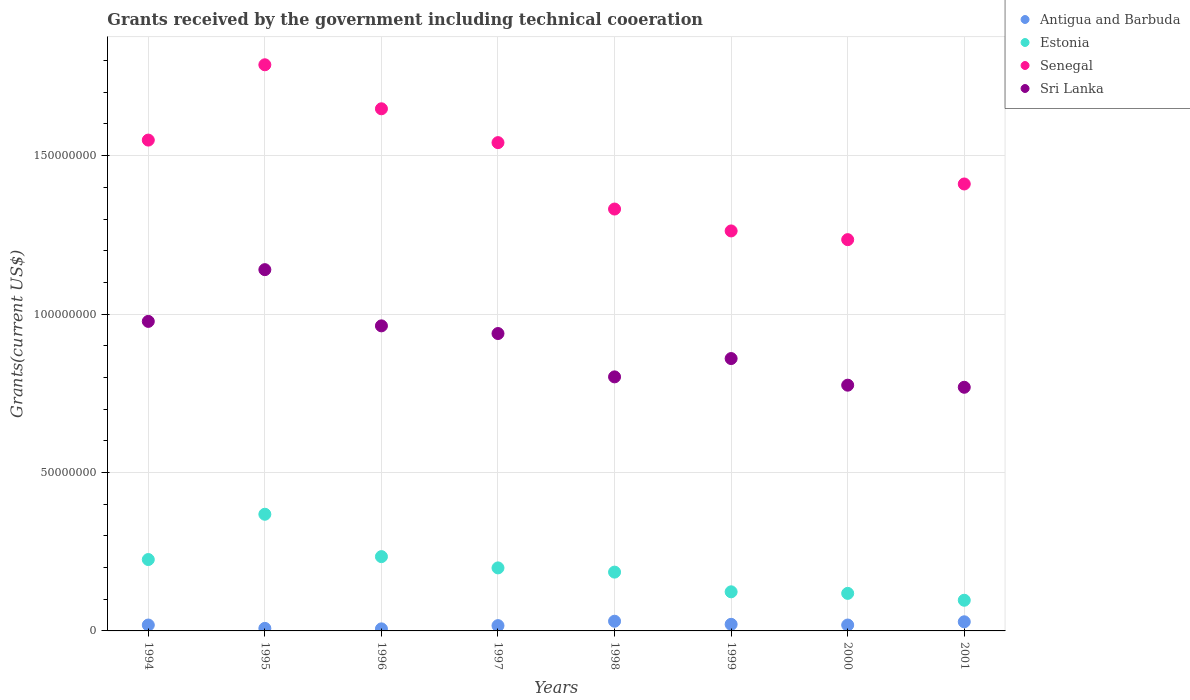How many different coloured dotlines are there?
Ensure brevity in your answer.  4. Is the number of dotlines equal to the number of legend labels?
Provide a succinct answer. Yes. What is the total grants received by the government in Estonia in 1999?
Keep it short and to the point. 1.23e+07. Across all years, what is the maximum total grants received by the government in Antigua and Barbuda?
Ensure brevity in your answer.  3.06e+06. Across all years, what is the minimum total grants received by the government in Senegal?
Make the answer very short. 1.23e+08. In which year was the total grants received by the government in Antigua and Barbuda maximum?
Your response must be concise. 1998. What is the total total grants received by the government in Estonia in the graph?
Your answer should be very brief. 1.55e+08. What is the difference between the total grants received by the government in Sri Lanka in 1994 and that in 1997?
Your answer should be compact. 3.83e+06. What is the difference between the total grants received by the government in Estonia in 1997 and the total grants received by the government in Antigua and Barbuda in 1995?
Keep it short and to the point. 1.91e+07. What is the average total grants received by the government in Senegal per year?
Your answer should be compact. 1.47e+08. In the year 1996, what is the difference between the total grants received by the government in Sri Lanka and total grants received by the government in Antigua and Barbuda?
Provide a succinct answer. 9.56e+07. In how many years, is the total grants received by the government in Antigua and Barbuda greater than 70000000 US$?
Offer a terse response. 0. What is the ratio of the total grants received by the government in Senegal in 2000 to that in 2001?
Provide a succinct answer. 0.88. Is the difference between the total grants received by the government in Sri Lanka in 1998 and 2001 greater than the difference between the total grants received by the government in Antigua and Barbuda in 1998 and 2001?
Your response must be concise. Yes. What is the difference between the highest and the second highest total grants received by the government in Estonia?
Your response must be concise. 1.34e+07. What is the difference between the highest and the lowest total grants received by the government in Antigua and Barbuda?
Keep it short and to the point. 2.41e+06. In how many years, is the total grants received by the government in Antigua and Barbuda greater than the average total grants received by the government in Antigua and Barbuda taken over all years?
Ensure brevity in your answer.  5. Is the sum of the total grants received by the government in Antigua and Barbuda in 1995 and 2000 greater than the maximum total grants received by the government in Estonia across all years?
Offer a very short reply. No. Is it the case that in every year, the sum of the total grants received by the government in Senegal and total grants received by the government in Estonia  is greater than the sum of total grants received by the government in Antigua and Barbuda and total grants received by the government in Sri Lanka?
Your answer should be very brief. Yes. Does the total grants received by the government in Sri Lanka monotonically increase over the years?
Your response must be concise. No. Is the total grants received by the government in Antigua and Barbuda strictly greater than the total grants received by the government in Sri Lanka over the years?
Offer a terse response. No. Is the total grants received by the government in Antigua and Barbuda strictly less than the total grants received by the government in Senegal over the years?
Offer a very short reply. Yes. How many dotlines are there?
Keep it short and to the point. 4. Are the values on the major ticks of Y-axis written in scientific E-notation?
Make the answer very short. No. Does the graph contain any zero values?
Make the answer very short. No. Does the graph contain grids?
Offer a terse response. Yes. Where does the legend appear in the graph?
Ensure brevity in your answer.  Top right. How are the legend labels stacked?
Ensure brevity in your answer.  Vertical. What is the title of the graph?
Provide a short and direct response. Grants received by the government including technical cooeration. Does "Malaysia" appear as one of the legend labels in the graph?
Keep it short and to the point. No. What is the label or title of the X-axis?
Your answer should be very brief. Years. What is the label or title of the Y-axis?
Keep it short and to the point. Grants(current US$). What is the Grants(current US$) of Antigua and Barbuda in 1994?
Provide a short and direct response. 1.86e+06. What is the Grants(current US$) in Estonia in 1994?
Provide a succinct answer. 2.25e+07. What is the Grants(current US$) in Senegal in 1994?
Your response must be concise. 1.55e+08. What is the Grants(current US$) of Sri Lanka in 1994?
Provide a succinct answer. 9.77e+07. What is the Grants(current US$) in Antigua and Barbuda in 1995?
Provide a succinct answer. 8.00e+05. What is the Grants(current US$) in Estonia in 1995?
Give a very brief answer. 3.68e+07. What is the Grants(current US$) in Senegal in 1995?
Keep it short and to the point. 1.79e+08. What is the Grants(current US$) of Sri Lanka in 1995?
Your answer should be very brief. 1.14e+08. What is the Grants(current US$) of Antigua and Barbuda in 1996?
Ensure brevity in your answer.  6.50e+05. What is the Grants(current US$) of Estonia in 1996?
Offer a very short reply. 2.34e+07. What is the Grants(current US$) of Senegal in 1996?
Offer a terse response. 1.65e+08. What is the Grants(current US$) in Sri Lanka in 1996?
Offer a very short reply. 9.63e+07. What is the Grants(current US$) of Antigua and Barbuda in 1997?
Make the answer very short. 1.67e+06. What is the Grants(current US$) in Estonia in 1997?
Your response must be concise. 1.99e+07. What is the Grants(current US$) of Senegal in 1997?
Keep it short and to the point. 1.54e+08. What is the Grants(current US$) in Sri Lanka in 1997?
Give a very brief answer. 9.39e+07. What is the Grants(current US$) in Antigua and Barbuda in 1998?
Provide a succinct answer. 3.06e+06. What is the Grants(current US$) of Estonia in 1998?
Your answer should be compact. 1.86e+07. What is the Grants(current US$) in Senegal in 1998?
Provide a succinct answer. 1.33e+08. What is the Grants(current US$) in Sri Lanka in 1998?
Provide a short and direct response. 8.02e+07. What is the Grants(current US$) of Antigua and Barbuda in 1999?
Your answer should be very brief. 2.08e+06. What is the Grants(current US$) of Estonia in 1999?
Your response must be concise. 1.23e+07. What is the Grants(current US$) of Senegal in 1999?
Make the answer very short. 1.26e+08. What is the Grants(current US$) in Sri Lanka in 1999?
Provide a succinct answer. 8.60e+07. What is the Grants(current US$) of Antigua and Barbuda in 2000?
Your answer should be compact. 1.86e+06. What is the Grants(current US$) of Estonia in 2000?
Your response must be concise. 1.18e+07. What is the Grants(current US$) of Senegal in 2000?
Keep it short and to the point. 1.23e+08. What is the Grants(current US$) in Sri Lanka in 2000?
Offer a terse response. 7.76e+07. What is the Grants(current US$) in Antigua and Barbuda in 2001?
Make the answer very short. 2.88e+06. What is the Grants(current US$) in Estonia in 2001?
Your answer should be compact. 9.68e+06. What is the Grants(current US$) in Senegal in 2001?
Offer a terse response. 1.41e+08. What is the Grants(current US$) of Sri Lanka in 2001?
Give a very brief answer. 7.69e+07. Across all years, what is the maximum Grants(current US$) of Antigua and Barbuda?
Make the answer very short. 3.06e+06. Across all years, what is the maximum Grants(current US$) in Estonia?
Offer a terse response. 3.68e+07. Across all years, what is the maximum Grants(current US$) in Senegal?
Make the answer very short. 1.79e+08. Across all years, what is the maximum Grants(current US$) in Sri Lanka?
Give a very brief answer. 1.14e+08. Across all years, what is the minimum Grants(current US$) of Antigua and Barbuda?
Ensure brevity in your answer.  6.50e+05. Across all years, what is the minimum Grants(current US$) of Estonia?
Offer a very short reply. 9.68e+06. Across all years, what is the minimum Grants(current US$) in Senegal?
Give a very brief answer. 1.23e+08. Across all years, what is the minimum Grants(current US$) of Sri Lanka?
Your answer should be compact. 7.69e+07. What is the total Grants(current US$) in Antigua and Barbuda in the graph?
Offer a terse response. 1.49e+07. What is the total Grants(current US$) in Estonia in the graph?
Your answer should be very brief. 1.55e+08. What is the total Grants(current US$) of Senegal in the graph?
Ensure brevity in your answer.  1.18e+09. What is the total Grants(current US$) of Sri Lanka in the graph?
Provide a short and direct response. 7.22e+08. What is the difference between the Grants(current US$) of Antigua and Barbuda in 1994 and that in 1995?
Make the answer very short. 1.06e+06. What is the difference between the Grants(current US$) of Estonia in 1994 and that in 1995?
Offer a very short reply. -1.43e+07. What is the difference between the Grants(current US$) of Senegal in 1994 and that in 1995?
Your answer should be very brief. -2.38e+07. What is the difference between the Grants(current US$) of Sri Lanka in 1994 and that in 1995?
Your response must be concise. -1.63e+07. What is the difference between the Grants(current US$) of Antigua and Barbuda in 1994 and that in 1996?
Offer a terse response. 1.21e+06. What is the difference between the Grants(current US$) of Estonia in 1994 and that in 1996?
Your answer should be very brief. -9.20e+05. What is the difference between the Grants(current US$) of Senegal in 1994 and that in 1996?
Provide a short and direct response. -9.88e+06. What is the difference between the Grants(current US$) in Sri Lanka in 1994 and that in 1996?
Ensure brevity in your answer.  1.41e+06. What is the difference between the Grants(current US$) in Estonia in 1994 and that in 1997?
Keep it short and to the point. 2.64e+06. What is the difference between the Grants(current US$) of Senegal in 1994 and that in 1997?
Ensure brevity in your answer.  8.00e+05. What is the difference between the Grants(current US$) in Sri Lanka in 1994 and that in 1997?
Provide a short and direct response. 3.83e+06. What is the difference between the Grants(current US$) in Antigua and Barbuda in 1994 and that in 1998?
Give a very brief answer. -1.20e+06. What is the difference between the Grants(current US$) of Estonia in 1994 and that in 1998?
Offer a terse response. 3.97e+06. What is the difference between the Grants(current US$) of Senegal in 1994 and that in 1998?
Make the answer very short. 2.18e+07. What is the difference between the Grants(current US$) of Sri Lanka in 1994 and that in 1998?
Give a very brief answer. 1.75e+07. What is the difference between the Grants(current US$) in Antigua and Barbuda in 1994 and that in 1999?
Offer a very short reply. -2.20e+05. What is the difference between the Grants(current US$) of Estonia in 1994 and that in 1999?
Offer a terse response. 1.02e+07. What is the difference between the Grants(current US$) of Senegal in 1994 and that in 1999?
Give a very brief answer. 2.87e+07. What is the difference between the Grants(current US$) in Sri Lanka in 1994 and that in 1999?
Give a very brief answer. 1.17e+07. What is the difference between the Grants(current US$) of Estonia in 1994 and that in 2000?
Your answer should be compact. 1.07e+07. What is the difference between the Grants(current US$) of Senegal in 1994 and that in 2000?
Provide a short and direct response. 3.14e+07. What is the difference between the Grants(current US$) of Sri Lanka in 1994 and that in 2000?
Your response must be concise. 2.01e+07. What is the difference between the Grants(current US$) in Antigua and Barbuda in 1994 and that in 2001?
Keep it short and to the point. -1.02e+06. What is the difference between the Grants(current US$) of Estonia in 1994 and that in 2001?
Offer a terse response. 1.28e+07. What is the difference between the Grants(current US$) in Senegal in 1994 and that in 2001?
Offer a very short reply. 1.38e+07. What is the difference between the Grants(current US$) of Sri Lanka in 1994 and that in 2001?
Your answer should be very brief. 2.08e+07. What is the difference between the Grants(current US$) of Antigua and Barbuda in 1995 and that in 1996?
Your answer should be very brief. 1.50e+05. What is the difference between the Grants(current US$) of Estonia in 1995 and that in 1996?
Ensure brevity in your answer.  1.34e+07. What is the difference between the Grants(current US$) of Senegal in 1995 and that in 1996?
Provide a succinct answer. 1.39e+07. What is the difference between the Grants(current US$) of Sri Lanka in 1995 and that in 1996?
Give a very brief answer. 1.77e+07. What is the difference between the Grants(current US$) of Antigua and Barbuda in 1995 and that in 1997?
Your response must be concise. -8.70e+05. What is the difference between the Grants(current US$) of Estonia in 1995 and that in 1997?
Give a very brief answer. 1.69e+07. What is the difference between the Grants(current US$) of Senegal in 1995 and that in 1997?
Provide a succinct answer. 2.46e+07. What is the difference between the Grants(current US$) of Sri Lanka in 1995 and that in 1997?
Make the answer very short. 2.02e+07. What is the difference between the Grants(current US$) in Antigua and Barbuda in 1995 and that in 1998?
Offer a terse response. -2.26e+06. What is the difference between the Grants(current US$) of Estonia in 1995 and that in 1998?
Provide a succinct answer. 1.83e+07. What is the difference between the Grants(current US$) in Senegal in 1995 and that in 1998?
Provide a succinct answer. 4.55e+07. What is the difference between the Grants(current US$) in Sri Lanka in 1995 and that in 1998?
Offer a terse response. 3.38e+07. What is the difference between the Grants(current US$) of Antigua and Barbuda in 1995 and that in 1999?
Your answer should be compact. -1.28e+06. What is the difference between the Grants(current US$) in Estonia in 1995 and that in 1999?
Ensure brevity in your answer.  2.45e+07. What is the difference between the Grants(current US$) in Senegal in 1995 and that in 1999?
Your response must be concise. 5.24e+07. What is the difference between the Grants(current US$) of Sri Lanka in 1995 and that in 1999?
Keep it short and to the point. 2.81e+07. What is the difference between the Grants(current US$) in Antigua and Barbuda in 1995 and that in 2000?
Your answer should be very brief. -1.06e+06. What is the difference between the Grants(current US$) in Estonia in 1995 and that in 2000?
Your answer should be very brief. 2.50e+07. What is the difference between the Grants(current US$) of Senegal in 1995 and that in 2000?
Offer a very short reply. 5.52e+07. What is the difference between the Grants(current US$) of Sri Lanka in 1995 and that in 2000?
Ensure brevity in your answer.  3.65e+07. What is the difference between the Grants(current US$) in Antigua and Barbuda in 1995 and that in 2001?
Provide a succinct answer. -2.08e+06. What is the difference between the Grants(current US$) in Estonia in 1995 and that in 2001?
Give a very brief answer. 2.71e+07. What is the difference between the Grants(current US$) in Senegal in 1995 and that in 2001?
Your response must be concise. 3.76e+07. What is the difference between the Grants(current US$) in Sri Lanka in 1995 and that in 2001?
Ensure brevity in your answer.  3.71e+07. What is the difference between the Grants(current US$) of Antigua and Barbuda in 1996 and that in 1997?
Keep it short and to the point. -1.02e+06. What is the difference between the Grants(current US$) of Estonia in 1996 and that in 1997?
Offer a very short reply. 3.56e+06. What is the difference between the Grants(current US$) of Senegal in 1996 and that in 1997?
Your answer should be very brief. 1.07e+07. What is the difference between the Grants(current US$) in Sri Lanka in 1996 and that in 1997?
Provide a succinct answer. 2.42e+06. What is the difference between the Grants(current US$) of Antigua and Barbuda in 1996 and that in 1998?
Give a very brief answer. -2.41e+06. What is the difference between the Grants(current US$) of Estonia in 1996 and that in 1998?
Your answer should be very brief. 4.89e+06. What is the difference between the Grants(current US$) of Senegal in 1996 and that in 1998?
Give a very brief answer. 3.16e+07. What is the difference between the Grants(current US$) in Sri Lanka in 1996 and that in 1998?
Offer a terse response. 1.61e+07. What is the difference between the Grants(current US$) in Antigua and Barbuda in 1996 and that in 1999?
Offer a very short reply. -1.43e+06. What is the difference between the Grants(current US$) in Estonia in 1996 and that in 1999?
Ensure brevity in your answer.  1.11e+07. What is the difference between the Grants(current US$) of Senegal in 1996 and that in 1999?
Provide a succinct answer. 3.86e+07. What is the difference between the Grants(current US$) in Sri Lanka in 1996 and that in 1999?
Provide a short and direct response. 1.03e+07. What is the difference between the Grants(current US$) of Antigua and Barbuda in 1996 and that in 2000?
Offer a very short reply. -1.21e+06. What is the difference between the Grants(current US$) of Estonia in 1996 and that in 2000?
Make the answer very short. 1.16e+07. What is the difference between the Grants(current US$) in Senegal in 1996 and that in 2000?
Offer a terse response. 4.13e+07. What is the difference between the Grants(current US$) in Sri Lanka in 1996 and that in 2000?
Offer a very short reply. 1.87e+07. What is the difference between the Grants(current US$) in Antigua and Barbuda in 1996 and that in 2001?
Make the answer very short. -2.23e+06. What is the difference between the Grants(current US$) in Estonia in 1996 and that in 2001?
Provide a succinct answer. 1.38e+07. What is the difference between the Grants(current US$) in Senegal in 1996 and that in 2001?
Offer a terse response. 2.37e+07. What is the difference between the Grants(current US$) of Sri Lanka in 1996 and that in 2001?
Your answer should be very brief. 1.94e+07. What is the difference between the Grants(current US$) of Antigua and Barbuda in 1997 and that in 1998?
Ensure brevity in your answer.  -1.39e+06. What is the difference between the Grants(current US$) of Estonia in 1997 and that in 1998?
Offer a very short reply. 1.33e+06. What is the difference between the Grants(current US$) of Senegal in 1997 and that in 1998?
Offer a very short reply. 2.10e+07. What is the difference between the Grants(current US$) in Sri Lanka in 1997 and that in 1998?
Your answer should be compact. 1.37e+07. What is the difference between the Grants(current US$) in Antigua and Barbuda in 1997 and that in 1999?
Your response must be concise. -4.10e+05. What is the difference between the Grants(current US$) in Estonia in 1997 and that in 1999?
Your response must be concise. 7.55e+06. What is the difference between the Grants(current US$) in Senegal in 1997 and that in 1999?
Ensure brevity in your answer.  2.79e+07. What is the difference between the Grants(current US$) of Sri Lanka in 1997 and that in 1999?
Provide a short and direct response. 7.90e+06. What is the difference between the Grants(current US$) of Estonia in 1997 and that in 2000?
Provide a short and direct response. 8.04e+06. What is the difference between the Grants(current US$) of Senegal in 1997 and that in 2000?
Your response must be concise. 3.06e+07. What is the difference between the Grants(current US$) of Sri Lanka in 1997 and that in 2000?
Your response must be concise. 1.63e+07. What is the difference between the Grants(current US$) in Antigua and Barbuda in 1997 and that in 2001?
Offer a terse response. -1.21e+06. What is the difference between the Grants(current US$) of Estonia in 1997 and that in 2001?
Offer a very short reply. 1.02e+07. What is the difference between the Grants(current US$) of Senegal in 1997 and that in 2001?
Give a very brief answer. 1.30e+07. What is the difference between the Grants(current US$) in Sri Lanka in 1997 and that in 2001?
Your response must be concise. 1.70e+07. What is the difference between the Grants(current US$) of Antigua and Barbuda in 1998 and that in 1999?
Offer a terse response. 9.80e+05. What is the difference between the Grants(current US$) in Estonia in 1998 and that in 1999?
Your answer should be very brief. 6.22e+06. What is the difference between the Grants(current US$) in Senegal in 1998 and that in 1999?
Your answer should be compact. 6.91e+06. What is the difference between the Grants(current US$) in Sri Lanka in 1998 and that in 1999?
Your answer should be very brief. -5.78e+06. What is the difference between the Grants(current US$) in Antigua and Barbuda in 1998 and that in 2000?
Your answer should be compact. 1.20e+06. What is the difference between the Grants(current US$) in Estonia in 1998 and that in 2000?
Ensure brevity in your answer.  6.71e+06. What is the difference between the Grants(current US$) in Senegal in 1998 and that in 2000?
Provide a succinct answer. 9.66e+06. What is the difference between the Grants(current US$) of Sri Lanka in 1998 and that in 2000?
Provide a short and direct response. 2.62e+06. What is the difference between the Grants(current US$) of Antigua and Barbuda in 1998 and that in 2001?
Your answer should be compact. 1.80e+05. What is the difference between the Grants(current US$) of Estonia in 1998 and that in 2001?
Provide a short and direct response. 8.88e+06. What is the difference between the Grants(current US$) in Senegal in 1998 and that in 2001?
Give a very brief answer. -7.91e+06. What is the difference between the Grants(current US$) in Sri Lanka in 1998 and that in 2001?
Your response must be concise. 3.28e+06. What is the difference between the Grants(current US$) of Antigua and Barbuda in 1999 and that in 2000?
Offer a very short reply. 2.20e+05. What is the difference between the Grants(current US$) in Senegal in 1999 and that in 2000?
Provide a succinct answer. 2.75e+06. What is the difference between the Grants(current US$) of Sri Lanka in 1999 and that in 2000?
Provide a short and direct response. 8.40e+06. What is the difference between the Grants(current US$) in Antigua and Barbuda in 1999 and that in 2001?
Keep it short and to the point. -8.00e+05. What is the difference between the Grants(current US$) in Estonia in 1999 and that in 2001?
Your answer should be compact. 2.66e+06. What is the difference between the Grants(current US$) of Senegal in 1999 and that in 2001?
Keep it short and to the point. -1.48e+07. What is the difference between the Grants(current US$) in Sri Lanka in 1999 and that in 2001?
Keep it short and to the point. 9.06e+06. What is the difference between the Grants(current US$) of Antigua and Barbuda in 2000 and that in 2001?
Your answer should be compact. -1.02e+06. What is the difference between the Grants(current US$) of Estonia in 2000 and that in 2001?
Offer a very short reply. 2.17e+06. What is the difference between the Grants(current US$) of Senegal in 2000 and that in 2001?
Provide a short and direct response. -1.76e+07. What is the difference between the Grants(current US$) of Antigua and Barbuda in 1994 and the Grants(current US$) of Estonia in 1995?
Your answer should be compact. -3.50e+07. What is the difference between the Grants(current US$) in Antigua and Barbuda in 1994 and the Grants(current US$) in Senegal in 1995?
Make the answer very short. -1.77e+08. What is the difference between the Grants(current US$) of Antigua and Barbuda in 1994 and the Grants(current US$) of Sri Lanka in 1995?
Ensure brevity in your answer.  -1.12e+08. What is the difference between the Grants(current US$) in Estonia in 1994 and the Grants(current US$) in Senegal in 1995?
Your answer should be compact. -1.56e+08. What is the difference between the Grants(current US$) of Estonia in 1994 and the Grants(current US$) of Sri Lanka in 1995?
Ensure brevity in your answer.  -9.15e+07. What is the difference between the Grants(current US$) in Senegal in 1994 and the Grants(current US$) in Sri Lanka in 1995?
Provide a short and direct response. 4.09e+07. What is the difference between the Grants(current US$) of Antigua and Barbuda in 1994 and the Grants(current US$) of Estonia in 1996?
Your response must be concise. -2.16e+07. What is the difference between the Grants(current US$) in Antigua and Barbuda in 1994 and the Grants(current US$) in Senegal in 1996?
Make the answer very short. -1.63e+08. What is the difference between the Grants(current US$) of Antigua and Barbuda in 1994 and the Grants(current US$) of Sri Lanka in 1996?
Give a very brief answer. -9.44e+07. What is the difference between the Grants(current US$) of Estonia in 1994 and the Grants(current US$) of Senegal in 1996?
Keep it short and to the point. -1.42e+08. What is the difference between the Grants(current US$) in Estonia in 1994 and the Grants(current US$) in Sri Lanka in 1996?
Your answer should be very brief. -7.38e+07. What is the difference between the Grants(current US$) of Senegal in 1994 and the Grants(current US$) of Sri Lanka in 1996?
Your answer should be compact. 5.86e+07. What is the difference between the Grants(current US$) of Antigua and Barbuda in 1994 and the Grants(current US$) of Estonia in 1997?
Provide a succinct answer. -1.80e+07. What is the difference between the Grants(current US$) of Antigua and Barbuda in 1994 and the Grants(current US$) of Senegal in 1997?
Give a very brief answer. -1.52e+08. What is the difference between the Grants(current US$) in Antigua and Barbuda in 1994 and the Grants(current US$) in Sri Lanka in 1997?
Your response must be concise. -9.20e+07. What is the difference between the Grants(current US$) in Estonia in 1994 and the Grants(current US$) in Senegal in 1997?
Your answer should be compact. -1.32e+08. What is the difference between the Grants(current US$) of Estonia in 1994 and the Grants(current US$) of Sri Lanka in 1997?
Ensure brevity in your answer.  -7.13e+07. What is the difference between the Grants(current US$) in Senegal in 1994 and the Grants(current US$) in Sri Lanka in 1997?
Offer a very short reply. 6.10e+07. What is the difference between the Grants(current US$) in Antigua and Barbuda in 1994 and the Grants(current US$) in Estonia in 1998?
Offer a very short reply. -1.67e+07. What is the difference between the Grants(current US$) in Antigua and Barbuda in 1994 and the Grants(current US$) in Senegal in 1998?
Keep it short and to the point. -1.31e+08. What is the difference between the Grants(current US$) in Antigua and Barbuda in 1994 and the Grants(current US$) in Sri Lanka in 1998?
Give a very brief answer. -7.83e+07. What is the difference between the Grants(current US$) in Estonia in 1994 and the Grants(current US$) in Senegal in 1998?
Ensure brevity in your answer.  -1.11e+08. What is the difference between the Grants(current US$) of Estonia in 1994 and the Grants(current US$) of Sri Lanka in 1998?
Ensure brevity in your answer.  -5.76e+07. What is the difference between the Grants(current US$) of Senegal in 1994 and the Grants(current US$) of Sri Lanka in 1998?
Provide a succinct answer. 7.47e+07. What is the difference between the Grants(current US$) of Antigua and Barbuda in 1994 and the Grants(current US$) of Estonia in 1999?
Your answer should be very brief. -1.05e+07. What is the difference between the Grants(current US$) of Antigua and Barbuda in 1994 and the Grants(current US$) of Senegal in 1999?
Keep it short and to the point. -1.24e+08. What is the difference between the Grants(current US$) of Antigua and Barbuda in 1994 and the Grants(current US$) of Sri Lanka in 1999?
Your answer should be very brief. -8.41e+07. What is the difference between the Grants(current US$) in Estonia in 1994 and the Grants(current US$) in Senegal in 1999?
Keep it short and to the point. -1.04e+08. What is the difference between the Grants(current US$) in Estonia in 1994 and the Grants(current US$) in Sri Lanka in 1999?
Your answer should be very brief. -6.34e+07. What is the difference between the Grants(current US$) of Senegal in 1994 and the Grants(current US$) of Sri Lanka in 1999?
Offer a very short reply. 6.90e+07. What is the difference between the Grants(current US$) in Antigua and Barbuda in 1994 and the Grants(current US$) in Estonia in 2000?
Give a very brief answer. -9.99e+06. What is the difference between the Grants(current US$) in Antigua and Barbuda in 1994 and the Grants(current US$) in Senegal in 2000?
Your answer should be compact. -1.22e+08. What is the difference between the Grants(current US$) of Antigua and Barbuda in 1994 and the Grants(current US$) of Sri Lanka in 2000?
Offer a terse response. -7.57e+07. What is the difference between the Grants(current US$) in Estonia in 1994 and the Grants(current US$) in Senegal in 2000?
Your answer should be very brief. -1.01e+08. What is the difference between the Grants(current US$) in Estonia in 1994 and the Grants(current US$) in Sri Lanka in 2000?
Keep it short and to the point. -5.50e+07. What is the difference between the Grants(current US$) of Senegal in 1994 and the Grants(current US$) of Sri Lanka in 2000?
Ensure brevity in your answer.  7.74e+07. What is the difference between the Grants(current US$) of Antigua and Barbuda in 1994 and the Grants(current US$) of Estonia in 2001?
Your answer should be compact. -7.82e+06. What is the difference between the Grants(current US$) of Antigua and Barbuda in 1994 and the Grants(current US$) of Senegal in 2001?
Your answer should be very brief. -1.39e+08. What is the difference between the Grants(current US$) of Antigua and Barbuda in 1994 and the Grants(current US$) of Sri Lanka in 2001?
Offer a very short reply. -7.50e+07. What is the difference between the Grants(current US$) of Estonia in 1994 and the Grants(current US$) of Senegal in 2001?
Make the answer very short. -1.19e+08. What is the difference between the Grants(current US$) in Estonia in 1994 and the Grants(current US$) in Sri Lanka in 2001?
Provide a succinct answer. -5.44e+07. What is the difference between the Grants(current US$) of Senegal in 1994 and the Grants(current US$) of Sri Lanka in 2001?
Offer a very short reply. 7.80e+07. What is the difference between the Grants(current US$) in Antigua and Barbuda in 1995 and the Grants(current US$) in Estonia in 1996?
Your answer should be very brief. -2.26e+07. What is the difference between the Grants(current US$) of Antigua and Barbuda in 1995 and the Grants(current US$) of Senegal in 1996?
Your answer should be very brief. -1.64e+08. What is the difference between the Grants(current US$) in Antigua and Barbuda in 1995 and the Grants(current US$) in Sri Lanka in 1996?
Provide a short and direct response. -9.55e+07. What is the difference between the Grants(current US$) in Estonia in 1995 and the Grants(current US$) in Senegal in 1996?
Keep it short and to the point. -1.28e+08. What is the difference between the Grants(current US$) of Estonia in 1995 and the Grants(current US$) of Sri Lanka in 1996?
Your response must be concise. -5.95e+07. What is the difference between the Grants(current US$) in Senegal in 1995 and the Grants(current US$) in Sri Lanka in 1996?
Keep it short and to the point. 8.24e+07. What is the difference between the Grants(current US$) of Antigua and Barbuda in 1995 and the Grants(current US$) of Estonia in 1997?
Your response must be concise. -1.91e+07. What is the difference between the Grants(current US$) in Antigua and Barbuda in 1995 and the Grants(current US$) in Senegal in 1997?
Your answer should be compact. -1.53e+08. What is the difference between the Grants(current US$) of Antigua and Barbuda in 1995 and the Grants(current US$) of Sri Lanka in 1997?
Provide a short and direct response. -9.31e+07. What is the difference between the Grants(current US$) of Estonia in 1995 and the Grants(current US$) of Senegal in 1997?
Your response must be concise. -1.17e+08. What is the difference between the Grants(current US$) in Estonia in 1995 and the Grants(current US$) in Sri Lanka in 1997?
Your answer should be compact. -5.70e+07. What is the difference between the Grants(current US$) in Senegal in 1995 and the Grants(current US$) in Sri Lanka in 1997?
Your answer should be very brief. 8.48e+07. What is the difference between the Grants(current US$) in Antigua and Barbuda in 1995 and the Grants(current US$) in Estonia in 1998?
Provide a short and direct response. -1.78e+07. What is the difference between the Grants(current US$) of Antigua and Barbuda in 1995 and the Grants(current US$) of Senegal in 1998?
Provide a succinct answer. -1.32e+08. What is the difference between the Grants(current US$) in Antigua and Barbuda in 1995 and the Grants(current US$) in Sri Lanka in 1998?
Your answer should be very brief. -7.94e+07. What is the difference between the Grants(current US$) of Estonia in 1995 and the Grants(current US$) of Senegal in 1998?
Give a very brief answer. -9.63e+07. What is the difference between the Grants(current US$) of Estonia in 1995 and the Grants(current US$) of Sri Lanka in 1998?
Offer a very short reply. -4.34e+07. What is the difference between the Grants(current US$) in Senegal in 1995 and the Grants(current US$) in Sri Lanka in 1998?
Offer a very short reply. 9.85e+07. What is the difference between the Grants(current US$) of Antigua and Barbuda in 1995 and the Grants(current US$) of Estonia in 1999?
Ensure brevity in your answer.  -1.15e+07. What is the difference between the Grants(current US$) in Antigua and Barbuda in 1995 and the Grants(current US$) in Senegal in 1999?
Give a very brief answer. -1.25e+08. What is the difference between the Grants(current US$) of Antigua and Barbuda in 1995 and the Grants(current US$) of Sri Lanka in 1999?
Give a very brief answer. -8.52e+07. What is the difference between the Grants(current US$) of Estonia in 1995 and the Grants(current US$) of Senegal in 1999?
Give a very brief answer. -8.94e+07. What is the difference between the Grants(current US$) in Estonia in 1995 and the Grants(current US$) in Sri Lanka in 1999?
Give a very brief answer. -4.91e+07. What is the difference between the Grants(current US$) of Senegal in 1995 and the Grants(current US$) of Sri Lanka in 1999?
Provide a succinct answer. 9.27e+07. What is the difference between the Grants(current US$) in Antigua and Barbuda in 1995 and the Grants(current US$) in Estonia in 2000?
Your answer should be compact. -1.10e+07. What is the difference between the Grants(current US$) of Antigua and Barbuda in 1995 and the Grants(current US$) of Senegal in 2000?
Make the answer very short. -1.23e+08. What is the difference between the Grants(current US$) of Antigua and Barbuda in 1995 and the Grants(current US$) of Sri Lanka in 2000?
Your answer should be very brief. -7.68e+07. What is the difference between the Grants(current US$) of Estonia in 1995 and the Grants(current US$) of Senegal in 2000?
Your answer should be compact. -8.67e+07. What is the difference between the Grants(current US$) of Estonia in 1995 and the Grants(current US$) of Sri Lanka in 2000?
Your response must be concise. -4.07e+07. What is the difference between the Grants(current US$) in Senegal in 1995 and the Grants(current US$) in Sri Lanka in 2000?
Give a very brief answer. 1.01e+08. What is the difference between the Grants(current US$) in Antigua and Barbuda in 1995 and the Grants(current US$) in Estonia in 2001?
Provide a short and direct response. -8.88e+06. What is the difference between the Grants(current US$) in Antigua and Barbuda in 1995 and the Grants(current US$) in Senegal in 2001?
Keep it short and to the point. -1.40e+08. What is the difference between the Grants(current US$) of Antigua and Barbuda in 1995 and the Grants(current US$) of Sri Lanka in 2001?
Provide a succinct answer. -7.61e+07. What is the difference between the Grants(current US$) of Estonia in 1995 and the Grants(current US$) of Senegal in 2001?
Offer a terse response. -1.04e+08. What is the difference between the Grants(current US$) in Estonia in 1995 and the Grants(current US$) in Sri Lanka in 2001?
Keep it short and to the point. -4.01e+07. What is the difference between the Grants(current US$) in Senegal in 1995 and the Grants(current US$) in Sri Lanka in 2001?
Your response must be concise. 1.02e+08. What is the difference between the Grants(current US$) in Antigua and Barbuda in 1996 and the Grants(current US$) in Estonia in 1997?
Provide a short and direct response. -1.92e+07. What is the difference between the Grants(current US$) of Antigua and Barbuda in 1996 and the Grants(current US$) of Senegal in 1997?
Give a very brief answer. -1.53e+08. What is the difference between the Grants(current US$) of Antigua and Barbuda in 1996 and the Grants(current US$) of Sri Lanka in 1997?
Your response must be concise. -9.32e+07. What is the difference between the Grants(current US$) of Estonia in 1996 and the Grants(current US$) of Senegal in 1997?
Give a very brief answer. -1.31e+08. What is the difference between the Grants(current US$) in Estonia in 1996 and the Grants(current US$) in Sri Lanka in 1997?
Give a very brief answer. -7.04e+07. What is the difference between the Grants(current US$) of Senegal in 1996 and the Grants(current US$) of Sri Lanka in 1997?
Give a very brief answer. 7.09e+07. What is the difference between the Grants(current US$) of Antigua and Barbuda in 1996 and the Grants(current US$) of Estonia in 1998?
Offer a terse response. -1.79e+07. What is the difference between the Grants(current US$) in Antigua and Barbuda in 1996 and the Grants(current US$) in Senegal in 1998?
Keep it short and to the point. -1.32e+08. What is the difference between the Grants(current US$) in Antigua and Barbuda in 1996 and the Grants(current US$) in Sri Lanka in 1998?
Your response must be concise. -7.95e+07. What is the difference between the Grants(current US$) of Estonia in 1996 and the Grants(current US$) of Senegal in 1998?
Make the answer very short. -1.10e+08. What is the difference between the Grants(current US$) in Estonia in 1996 and the Grants(current US$) in Sri Lanka in 1998?
Give a very brief answer. -5.67e+07. What is the difference between the Grants(current US$) in Senegal in 1996 and the Grants(current US$) in Sri Lanka in 1998?
Ensure brevity in your answer.  8.46e+07. What is the difference between the Grants(current US$) of Antigua and Barbuda in 1996 and the Grants(current US$) of Estonia in 1999?
Give a very brief answer. -1.17e+07. What is the difference between the Grants(current US$) of Antigua and Barbuda in 1996 and the Grants(current US$) of Senegal in 1999?
Keep it short and to the point. -1.26e+08. What is the difference between the Grants(current US$) of Antigua and Barbuda in 1996 and the Grants(current US$) of Sri Lanka in 1999?
Give a very brief answer. -8.53e+07. What is the difference between the Grants(current US$) in Estonia in 1996 and the Grants(current US$) in Senegal in 1999?
Ensure brevity in your answer.  -1.03e+08. What is the difference between the Grants(current US$) of Estonia in 1996 and the Grants(current US$) of Sri Lanka in 1999?
Your response must be concise. -6.25e+07. What is the difference between the Grants(current US$) of Senegal in 1996 and the Grants(current US$) of Sri Lanka in 1999?
Your response must be concise. 7.88e+07. What is the difference between the Grants(current US$) of Antigua and Barbuda in 1996 and the Grants(current US$) of Estonia in 2000?
Your answer should be compact. -1.12e+07. What is the difference between the Grants(current US$) of Antigua and Barbuda in 1996 and the Grants(current US$) of Senegal in 2000?
Offer a terse response. -1.23e+08. What is the difference between the Grants(current US$) in Antigua and Barbuda in 1996 and the Grants(current US$) in Sri Lanka in 2000?
Your answer should be compact. -7.69e+07. What is the difference between the Grants(current US$) of Estonia in 1996 and the Grants(current US$) of Senegal in 2000?
Your answer should be very brief. -1.00e+08. What is the difference between the Grants(current US$) in Estonia in 1996 and the Grants(current US$) in Sri Lanka in 2000?
Your response must be concise. -5.41e+07. What is the difference between the Grants(current US$) of Senegal in 1996 and the Grants(current US$) of Sri Lanka in 2000?
Your answer should be very brief. 8.72e+07. What is the difference between the Grants(current US$) of Antigua and Barbuda in 1996 and the Grants(current US$) of Estonia in 2001?
Your answer should be very brief. -9.03e+06. What is the difference between the Grants(current US$) in Antigua and Barbuda in 1996 and the Grants(current US$) in Senegal in 2001?
Keep it short and to the point. -1.40e+08. What is the difference between the Grants(current US$) in Antigua and Barbuda in 1996 and the Grants(current US$) in Sri Lanka in 2001?
Give a very brief answer. -7.62e+07. What is the difference between the Grants(current US$) of Estonia in 1996 and the Grants(current US$) of Senegal in 2001?
Ensure brevity in your answer.  -1.18e+08. What is the difference between the Grants(current US$) of Estonia in 1996 and the Grants(current US$) of Sri Lanka in 2001?
Keep it short and to the point. -5.34e+07. What is the difference between the Grants(current US$) of Senegal in 1996 and the Grants(current US$) of Sri Lanka in 2001?
Your response must be concise. 8.79e+07. What is the difference between the Grants(current US$) in Antigua and Barbuda in 1997 and the Grants(current US$) in Estonia in 1998?
Provide a succinct answer. -1.69e+07. What is the difference between the Grants(current US$) in Antigua and Barbuda in 1997 and the Grants(current US$) in Senegal in 1998?
Provide a succinct answer. -1.31e+08. What is the difference between the Grants(current US$) of Antigua and Barbuda in 1997 and the Grants(current US$) of Sri Lanka in 1998?
Offer a very short reply. -7.85e+07. What is the difference between the Grants(current US$) of Estonia in 1997 and the Grants(current US$) of Senegal in 1998?
Make the answer very short. -1.13e+08. What is the difference between the Grants(current US$) in Estonia in 1997 and the Grants(current US$) in Sri Lanka in 1998?
Your answer should be very brief. -6.03e+07. What is the difference between the Grants(current US$) of Senegal in 1997 and the Grants(current US$) of Sri Lanka in 1998?
Your answer should be compact. 7.39e+07. What is the difference between the Grants(current US$) in Antigua and Barbuda in 1997 and the Grants(current US$) in Estonia in 1999?
Your answer should be compact. -1.07e+07. What is the difference between the Grants(current US$) of Antigua and Barbuda in 1997 and the Grants(current US$) of Senegal in 1999?
Give a very brief answer. -1.25e+08. What is the difference between the Grants(current US$) of Antigua and Barbuda in 1997 and the Grants(current US$) of Sri Lanka in 1999?
Give a very brief answer. -8.43e+07. What is the difference between the Grants(current US$) of Estonia in 1997 and the Grants(current US$) of Senegal in 1999?
Keep it short and to the point. -1.06e+08. What is the difference between the Grants(current US$) of Estonia in 1997 and the Grants(current US$) of Sri Lanka in 1999?
Give a very brief answer. -6.61e+07. What is the difference between the Grants(current US$) of Senegal in 1997 and the Grants(current US$) of Sri Lanka in 1999?
Offer a terse response. 6.82e+07. What is the difference between the Grants(current US$) in Antigua and Barbuda in 1997 and the Grants(current US$) in Estonia in 2000?
Your answer should be very brief. -1.02e+07. What is the difference between the Grants(current US$) of Antigua and Barbuda in 1997 and the Grants(current US$) of Senegal in 2000?
Offer a terse response. -1.22e+08. What is the difference between the Grants(current US$) of Antigua and Barbuda in 1997 and the Grants(current US$) of Sri Lanka in 2000?
Offer a very short reply. -7.59e+07. What is the difference between the Grants(current US$) of Estonia in 1997 and the Grants(current US$) of Senegal in 2000?
Your answer should be compact. -1.04e+08. What is the difference between the Grants(current US$) in Estonia in 1997 and the Grants(current US$) in Sri Lanka in 2000?
Provide a succinct answer. -5.77e+07. What is the difference between the Grants(current US$) in Senegal in 1997 and the Grants(current US$) in Sri Lanka in 2000?
Keep it short and to the point. 7.66e+07. What is the difference between the Grants(current US$) of Antigua and Barbuda in 1997 and the Grants(current US$) of Estonia in 2001?
Keep it short and to the point. -8.01e+06. What is the difference between the Grants(current US$) of Antigua and Barbuda in 1997 and the Grants(current US$) of Senegal in 2001?
Your response must be concise. -1.39e+08. What is the difference between the Grants(current US$) in Antigua and Barbuda in 1997 and the Grants(current US$) in Sri Lanka in 2001?
Keep it short and to the point. -7.52e+07. What is the difference between the Grants(current US$) of Estonia in 1997 and the Grants(current US$) of Senegal in 2001?
Provide a succinct answer. -1.21e+08. What is the difference between the Grants(current US$) of Estonia in 1997 and the Grants(current US$) of Sri Lanka in 2001?
Provide a succinct answer. -5.70e+07. What is the difference between the Grants(current US$) in Senegal in 1997 and the Grants(current US$) in Sri Lanka in 2001?
Offer a very short reply. 7.72e+07. What is the difference between the Grants(current US$) in Antigua and Barbuda in 1998 and the Grants(current US$) in Estonia in 1999?
Keep it short and to the point. -9.28e+06. What is the difference between the Grants(current US$) in Antigua and Barbuda in 1998 and the Grants(current US$) in Senegal in 1999?
Your answer should be compact. -1.23e+08. What is the difference between the Grants(current US$) in Antigua and Barbuda in 1998 and the Grants(current US$) in Sri Lanka in 1999?
Provide a succinct answer. -8.29e+07. What is the difference between the Grants(current US$) in Estonia in 1998 and the Grants(current US$) in Senegal in 1999?
Provide a short and direct response. -1.08e+08. What is the difference between the Grants(current US$) of Estonia in 1998 and the Grants(current US$) of Sri Lanka in 1999?
Provide a short and direct response. -6.74e+07. What is the difference between the Grants(current US$) in Senegal in 1998 and the Grants(current US$) in Sri Lanka in 1999?
Give a very brief answer. 4.72e+07. What is the difference between the Grants(current US$) in Antigua and Barbuda in 1998 and the Grants(current US$) in Estonia in 2000?
Make the answer very short. -8.79e+06. What is the difference between the Grants(current US$) of Antigua and Barbuda in 1998 and the Grants(current US$) of Senegal in 2000?
Keep it short and to the point. -1.20e+08. What is the difference between the Grants(current US$) of Antigua and Barbuda in 1998 and the Grants(current US$) of Sri Lanka in 2000?
Your response must be concise. -7.45e+07. What is the difference between the Grants(current US$) of Estonia in 1998 and the Grants(current US$) of Senegal in 2000?
Your answer should be compact. -1.05e+08. What is the difference between the Grants(current US$) in Estonia in 1998 and the Grants(current US$) in Sri Lanka in 2000?
Give a very brief answer. -5.90e+07. What is the difference between the Grants(current US$) in Senegal in 1998 and the Grants(current US$) in Sri Lanka in 2000?
Your response must be concise. 5.56e+07. What is the difference between the Grants(current US$) of Antigua and Barbuda in 1998 and the Grants(current US$) of Estonia in 2001?
Your answer should be very brief. -6.62e+06. What is the difference between the Grants(current US$) in Antigua and Barbuda in 1998 and the Grants(current US$) in Senegal in 2001?
Your answer should be compact. -1.38e+08. What is the difference between the Grants(current US$) of Antigua and Barbuda in 1998 and the Grants(current US$) of Sri Lanka in 2001?
Provide a succinct answer. -7.38e+07. What is the difference between the Grants(current US$) in Estonia in 1998 and the Grants(current US$) in Senegal in 2001?
Your response must be concise. -1.22e+08. What is the difference between the Grants(current US$) in Estonia in 1998 and the Grants(current US$) in Sri Lanka in 2001?
Your response must be concise. -5.83e+07. What is the difference between the Grants(current US$) in Senegal in 1998 and the Grants(current US$) in Sri Lanka in 2001?
Provide a short and direct response. 5.62e+07. What is the difference between the Grants(current US$) in Antigua and Barbuda in 1999 and the Grants(current US$) in Estonia in 2000?
Your answer should be compact. -9.77e+06. What is the difference between the Grants(current US$) in Antigua and Barbuda in 1999 and the Grants(current US$) in Senegal in 2000?
Offer a very short reply. -1.21e+08. What is the difference between the Grants(current US$) of Antigua and Barbuda in 1999 and the Grants(current US$) of Sri Lanka in 2000?
Give a very brief answer. -7.55e+07. What is the difference between the Grants(current US$) of Estonia in 1999 and the Grants(current US$) of Senegal in 2000?
Keep it short and to the point. -1.11e+08. What is the difference between the Grants(current US$) of Estonia in 1999 and the Grants(current US$) of Sri Lanka in 2000?
Provide a succinct answer. -6.52e+07. What is the difference between the Grants(current US$) of Senegal in 1999 and the Grants(current US$) of Sri Lanka in 2000?
Offer a very short reply. 4.87e+07. What is the difference between the Grants(current US$) of Antigua and Barbuda in 1999 and the Grants(current US$) of Estonia in 2001?
Give a very brief answer. -7.60e+06. What is the difference between the Grants(current US$) of Antigua and Barbuda in 1999 and the Grants(current US$) of Senegal in 2001?
Your response must be concise. -1.39e+08. What is the difference between the Grants(current US$) in Antigua and Barbuda in 1999 and the Grants(current US$) in Sri Lanka in 2001?
Offer a very short reply. -7.48e+07. What is the difference between the Grants(current US$) in Estonia in 1999 and the Grants(current US$) in Senegal in 2001?
Make the answer very short. -1.29e+08. What is the difference between the Grants(current US$) of Estonia in 1999 and the Grants(current US$) of Sri Lanka in 2001?
Provide a succinct answer. -6.46e+07. What is the difference between the Grants(current US$) of Senegal in 1999 and the Grants(current US$) of Sri Lanka in 2001?
Your response must be concise. 4.93e+07. What is the difference between the Grants(current US$) of Antigua and Barbuda in 2000 and the Grants(current US$) of Estonia in 2001?
Ensure brevity in your answer.  -7.82e+06. What is the difference between the Grants(current US$) of Antigua and Barbuda in 2000 and the Grants(current US$) of Senegal in 2001?
Provide a short and direct response. -1.39e+08. What is the difference between the Grants(current US$) in Antigua and Barbuda in 2000 and the Grants(current US$) in Sri Lanka in 2001?
Give a very brief answer. -7.50e+07. What is the difference between the Grants(current US$) of Estonia in 2000 and the Grants(current US$) of Senegal in 2001?
Your answer should be compact. -1.29e+08. What is the difference between the Grants(current US$) in Estonia in 2000 and the Grants(current US$) in Sri Lanka in 2001?
Keep it short and to the point. -6.50e+07. What is the difference between the Grants(current US$) in Senegal in 2000 and the Grants(current US$) in Sri Lanka in 2001?
Your response must be concise. 4.66e+07. What is the average Grants(current US$) in Antigua and Barbuda per year?
Offer a terse response. 1.86e+06. What is the average Grants(current US$) in Estonia per year?
Give a very brief answer. 1.94e+07. What is the average Grants(current US$) of Senegal per year?
Provide a succinct answer. 1.47e+08. What is the average Grants(current US$) of Sri Lanka per year?
Keep it short and to the point. 9.03e+07. In the year 1994, what is the difference between the Grants(current US$) of Antigua and Barbuda and Grants(current US$) of Estonia?
Your answer should be compact. -2.07e+07. In the year 1994, what is the difference between the Grants(current US$) in Antigua and Barbuda and Grants(current US$) in Senegal?
Make the answer very short. -1.53e+08. In the year 1994, what is the difference between the Grants(current US$) of Antigua and Barbuda and Grants(current US$) of Sri Lanka?
Provide a short and direct response. -9.58e+07. In the year 1994, what is the difference between the Grants(current US$) of Estonia and Grants(current US$) of Senegal?
Your response must be concise. -1.32e+08. In the year 1994, what is the difference between the Grants(current US$) of Estonia and Grants(current US$) of Sri Lanka?
Make the answer very short. -7.52e+07. In the year 1994, what is the difference between the Grants(current US$) in Senegal and Grants(current US$) in Sri Lanka?
Give a very brief answer. 5.72e+07. In the year 1995, what is the difference between the Grants(current US$) of Antigua and Barbuda and Grants(current US$) of Estonia?
Offer a very short reply. -3.60e+07. In the year 1995, what is the difference between the Grants(current US$) of Antigua and Barbuda and Grants(current US$) of Senegal?
Keep it short and to the point. -1.78e+08. In the year 1995, what is the difference between the Grants(current US$) of Antigua and Barbuda and Grants(current US$) of Sri Lanka?
Make the answer very short. -1.13e+08. In the year 1995, what is the difference between the Grants(current US$) of Estonia and Grants(current US$) of Senegal?
Give a very brief answer. -1.42e+08. In the year 1995, what is the difference between the Grants(current US$) in Estonia and Grants(current US$) in Sri Lanka?
Offer a terse response. -7.72e+07. In the year 1995, what is the difference between the Grants(current US$) in Senegal and Grants(current US$) in Sri Lanka?
Your answer should be very brief. 6.47e+07. In the year 1996, what is the difference between the Grants(current US$) in Antigua and Barbuda and Grants(current US$) in Estonia?
Offer a very short reply. -2.28e+07. In the year 1996, what is the difference between the Grants(current US$) in Antigua and Barbuda and Grants(current US$) in Senegal?
Your answer should be very brief. -1.64e+08. In the year 1996, what is the difference between the Grants(current US$) of Antigua and Barbuda and Grants(current US$) of Sri Lanka?
Offer a terse response. -9.56e+07. In the year 1996, what is the difference between the Grants(current US$) in Estonia and Grants(current US$) in Senegal?
Keep it short and to the point. -1.41e+08. In the year 1996, what is the difference between the Grants(current US$) in Estonia and Grants(current US$) in Sri Lanka?
Offer a very short reply. -7.28e+07. In the year 1996, what is the difference between the Grants(current US$) in Senegal and Grants(current US$) in Sri Lanka?
Offer a terse response. 6.85e+07. In the year 1997, what is the difference between the Grants(current US$) in Antigua and Barbuda and Grants(current US$) in Estonia?
Make the answer very short. -1.82e+07. In the year 1997, what is the difference between the Grants(current US$) in Antigua and Barbuda and Grants(current US$) in Senegal?
Ensure brevity in your answer.  -1.52e+08. In the year 1997, what is the difference between the Grants(current US$) of Antigua and Barbuda and Grants(current US$) of Sri Lanka?
Your answer should be very brief. -9.22e+07. In the year 1997, what is the difference between the Grants(current US$) in Estonia and Grants(current US$) in Senegal?
Offer a terse response. -1.34e+08. In the year 1997, what is the difference between the Grants(current US$) of Estonia and Grants(current US$) of Sri Lanka?
Provide a short and direct response. -7.40e+07. In the year 1997, what is the difference between the Grants(current US$) of Senegal and Grants(current US$) of Sri Lanka?
Give a very brief answer. 6.02e+07. In the year 1998, what is the difference between the Grants(current US$) in Antigua and Barbuda and Grants(current US$) in Estonia?
Make the answer very short. -1.55e+07. In the year 1998, what is the difference between the Grants(current US$) of Antigua and Barbuda and Grants(current US$) of Senegal?
Your response must be concise. -1.30e+08. In the year 1998, what is the difference between the Grants(current US$) of Antigua and Barbuda and Grants(current US$) of Sri Lanka?
Offer a terse response. -7.71e+07. In the year 1998, what is the difference between the Grants(current US$) in Estonia and Grants(current US$) in Senegal?
Make the answer very short. -1.15e+08. In the year 1998, what is the difference between the Grants(current US$) of Estonia and Grants(current US$) of Sri Lanka?
Keep it short and to the point. -6.16e+07. In the year 1998, what is the difference between the Grants(current US$) of Senegal and Grants(current US$) of Sri Lanka?
Ensure brevity in your answer.  5.30e+07. In the year 1999, what is the difference between the Grants(current US$) of Antigua and Barbuda and Grants(current US$) of Estonia?
Give a very brief answer. -1.03e+07. In the year 1999, what is the difference between the Grants(current US$) of Antigua and Barbuda and Grants(current US$) of Senegal?
Your answer should be very brief. -1.24e+08. In the year 1999, what is the difference between the Grants(current US$) in Antigua and Barbuda and Grants(current US$) in Sri Lanka?
Give a very brief answer. -8.39e+07. In the year 1999, what is the difference between the Grants(current US$) of Estonia and Grants(current US$) of Senegal?
Offer a terse response. -1.14e+08. In the year 1999, what is the difference between the Grants(current US$) of Estonia and Grants(current US$) of Sri Lanka?
Your answer should be compact. -7.36e+07. In the year 1999, what is the difference between the Grants(current US$) in Senegal and Grants(current US$) in Sri Lanka?
Offer a very short reply. 4.03e+07. In the year 2000, what is the difference between the Grants(current US$) of Antigua and Barbuda and Grants(current US$) of Estonia?
Ensure brevity in your answer.  -9.99e+06. In the year 2000, what is the difference between the Grants(current US$) in Antigua and Barbuda and Grants(current US$) in Senegal?
Make the answer very short. -1.22e+08. In the year 2000, what is the difference between the Grants(current US$) in Antigua and Barbuda and Grants(current US$) in Sri Lanka?
Your response must be concise. -7.57e+07. In the year 2000, what is the difference between the Grants(current US$) of Estonia and Grants(current US$) of Senegal?
Your answer should be compact. -1.12e+08. In the year 2000, what is the difference between the Grants(current US$) of Estonia and Grants(current US$) of Sri Lanka?
Your answer should be very brief. -6.57e+07. In the year 2000, what is the difference between the Grants(current US$) in Senegal and Grants(current US$) in Sri Lanka?
Your response must be concise. 4.59e+07. In the year 2001, what is the difference between the Grants(current US$) of Antigua and Barbuda and Grants(current US$) of Estonia?
Give a very brief answer. -6.80e+06. In the year 2001, what is the difference between the Grants(current US$) in Antigua and Barbuda and Grants(current US$) in Senegal?
Offer a very short reply. -1.38e+08. In the year 2001, what is the difference between the Grants(current US$) in Antigua and Barbuda and Grants(current US$) in Sri Lanka?
Your answer should be very brief. -7.40e+07. In the year 2001, what is the difference between the Grants(current US$) of Estonia and Grants(current US$) of Senegal?
Provide a succinct answer. -1.31e+08. In the year 2001, what is the difference between the Grants(current US$) in Estonia and Grants(current US$) in Sri Lanka?
Offer a very short reply. -6.72e+07. In the year 2001, what is the difference between the Grants(current US$) in Senegal and Grants(current US$) in Sri Lanka?
Keep it short and to the point. 6.42e+07. What is the ratio of the Grants(current US$) of Antigua and Barbuda in 1994 to that in 1995?
Your response must be concise. 2.33. What is the ratio of the Grants(current US$) of Estonia in 1994 to that in 1995?
Offer a very short reply. 0.61. What is the ratio of the Grants(current US$) in Senegal in 1994 to that in 1995?
Your answer should be compact. 0.87. What is the ratio of the Grants(current US$) of Sri Lanka in 1994 to that in 1995?
Provide a succinct answer. 0.86. What is the ratio of the Grants(current US$) in Antigua and Barbuda in 1994 to that in 1996?
Provide a short and direct response. 2.86. What is the ratio of the Grants(current US$) of Estonia in 1994 to that in 1996?
Ensure brevity in your answer.  0.96. What is the ratio of the Grants(current US$) of Sri Lanka in 1994 to that in 1996?
Your answer should be compact. 1.01. What is the ratio of the Grants(current US$) in Antigua and Barbuda in 1994 to that in 1997?
Ensure brevity in your answer.  1.11. What is the ratio of the Grants(current US$) of Estonia in 1994 to that in 1997?
Your response must be concise. 1.13. What is the ratio of the Grants(current US$) of Sri Lanka in 1994 to that in 1997?
Keep it short and to the point. 1.04. What is the ratio of the Grants(current US$) of Antigua and Barbuda in 1994 to that in 1998?
Offer a terse response. 0.61. What is the ratio of the Grants(current US$) in Estonia in 1994 to that in 1998?
Offer a very short reply. 1.21. What is the ratio of the Grants(current US$) in Senegal in 1994 to that in 1998?
Your answer should be very brief. 1.16. What is the ratio of the Grants(current US$) of Sri Lanka in 1994 to that in 1998?
Ensure brevity in your answer.  1.22. What is the ratio of the Grants(current US$) in Antigua and Barbuda in 1994 to that in 1999?
Offer a terse response. 0.89. What is the ratio of the Grants(current US$) in Estonia in 1994 to that in 1999?
Offer a very short reply. 1.83. What is the ratio of the Grants(current US$) of Senegal in 1994 to that in 1999?
Provide a short and direct response. 1.23. What is the ratio of the Grants(current US$) of Sri Lanka in 1994 to that in 1999?
Offer a terse response. 1.14. What is the ratio of the Grants(current US$) of Antigua and Barbuda in 1994 to that in 2000?
Provide a succinct answer. 1. What is the ratio of the Grants(current US$) in Estonia in 1994 to that in 2000?
Give a very brief answer. 1.9. What is the ratio of the Grants(current US$) of Senegal in 1994 to that in 2000?
Give a very brief answer. 1.25. What is the ratio of the Grants(current US$) in Sri Lanka in 1994 to that in 2000?
Provide a succinct answer. 1.26. What is the ratio of the Grants(current US$) of Antigua and Barbuda in 1994 to that in 2001?
Your answer should be compact. 0.65. What is the ratio of the Grants(current US$) in Estonia in 1994 to that in 2001?
Offer a very short reply. 2.33. What is the ratio of the Grants(current US$) in Senegal in 1994 to that in 2001?
Ensure brevity in your answer.  1.1. What is the ratio of the Grants(current US$) in Sri Lanka in 1994 to that in 2001?
Your answer should be compact. 1.27. What is the ratio of the Grants(current US$) of Antigua and Barbuda in 1995 to that in 1996?
Your answer should be very brief. 1.23. What is the ratio of the Grants(current US$) of Estonia in 1995 to that in 1996?
Provide a succinct answer. 1.57. What is the ratio of the Grants(current US$) of Senegal in 1995 to that in 1996?
Provide a short and direct response. 1.08. What is the ratio of the Grants(current US$) in Sri Lanka in 1995 to that in 1996?
Provide a short and direct response. 1.18. What is the ratio of the Grants(current US$) in Antigua and Barbuda in 1995 to that in 1997?
Make the answer very short. 0.48. What is the ratio of the Grants(current US$) in Estonia in 1995 to that in 1997?
Your answer should be very brief. 1.85. What is the ratio of the Grants(current US$) of Senegal in 1995 to that in 1997?
Your response must be concise. 1.16. What is the ratio of the Grants(current US$) in Sri Lanka in 1995 to that in 1997?
Your response must be concise. 1.21. What is the ratio of the Grants(current US$) in Antigua and Barbuda in 1995 to that in 1998?
Your response must be concise. 0.26. What is the ratio of the Grants(current US$) in Estonia in 1995 to that in 1998?
Your response must be concise. 1.98. What is the ratio of the Grants(current US$) of Senegal in 1995 to that in 1998?
Provide a succinct answer. 1.34. What is the ratio of the Grants(current US$) in Sri Lanka in 1995 to that in 1998?
Your answer should be very brief. 1.42. What is the ratio of the Grants(current US$) in Antigua and Barbuda in 1995 to that in 1999?
Ensure brevity in your answer.  0.38. What is the ratio of the Grants(current US$) in Estonia in 1995 to that in 1999?
Provide a succinct answer. 2.98. What is the ratio of the Grants(current US$) of Senegal in 1995 to that in 1999?
Make the answer very short. 1.42. What is the ratio of the Grants(current US$) of Sri Lanka in 1995 to that in 1999?
Your answer should be very brief. 1.33. What is the ratio of the Grants(current US$) of Antigua and Barbuda in 1995 to that in 2000?
Offer a very short reply. 0.43. What is the ratio of the Grants(current US$) of Estonia in 1995 to that in 2000?
Provide a short and direct response. 3.11. What is the ratio of the Grants(current US$) in Senegal in 1995 to that in 2000?
Make the answer very short. 1.45. What is the ratio of the Grants(current US$) in Sri Lanka in 1995 to that in 2000?
Ensure brevity in your answer.  1.47. What is the ratio of the Grants(current US$) of Antigua and Barbuda in 1995 to that in 2001?
Make the answer very short. 0.28. What is the ratio of the Grants(current US$) in Estonia in 1995 to that in 2001?
Keep it short and to the point. 3.8. What is the ratio of the Grants(current US$) in Senegal in 1995 to that in 2001?
Your answer should be compact. 1.27. What is the ratio of the Grants(current US$) in Sri Lanka in 1995 to that in 2001?
Give a very brief answer. 1.48. What is the ratio of the Grants(current US$) in Antigua and Barbuda in 1996 to that in 1997?
Offer a very short reply. 0.39. What is the ratio of the Grants(current US$) of Estonia in 1996 to that in 1997?
Provide a succinct answer. 1.18. What is the ratio of the Grants(current US$) in Senegal in 1996 to that in 1997?
Provide a succinct answer. 1.07. What is the ratio of the Grants(current US$) in Sri Lanka in 1996 to that in 1997?
Your response must be concise. 1.03. What is the ratio of the Grants(current US$) of Antigua and Barbuda in 1996 to that in 1998?
Provide a succinct answer. 0.21. What is the ratio of the Grants(current US$) in Estonia in 1996 to that in 1998?
Provide a short and direct response. 1.26. What is the ratio of the Grants(current US$) in Senegal in 1996 to that in 1998?
Your response must be concise. 1.24. What is the ratio of the Grants(current US$) of Sri Lanka in 1996 to that in 1998?
Your response must be concise. 1.2. What is the ratio of the Grants(current US$) in Antigua and Barbuda in 1996 to that in 1999?
Offer a very short reply. 0.31. What is the ratio of the Grants(current US$) of Estonia in 1996 to that in 1999?
Your answer should be compact. 1.9. What is the ratio of the Grants(current US$) in Senegal in 1996 to that in 1999?
Your answer should be compact. 1.31. What is the ratio of the Grants(current US$) in Sri Lanka in 1996 to that in 1999?
Provide a short and direct response. 1.12. What is the ratio of the Grants(current US$) of Antigua and Barbuda in 1996 to that in 2000?
Provide a succinct answer. 0.35. What is the ratio of the Grants(current US$) in Estonia in 1996 to that in 2000?
Your answer should be compact. 1.98. What is the ratio of the Grants(current US$) in Senegal in 1996 to that in 2000?
Your answer should be very brief. 1.33. What is the ratio of the Grants(current US$) of Sri Lanka in 1996 to that in 2000?
Your answer should be compact. 1.24. What is the ratio of the Grants(current US$) of Antigua and Barbuda in 1996 to that in 2001?
Provide a short and direct response. 0.23. What is the ratio of the Grants(current US$) in Estonia in 1996 to that in 2001?
Offer a very short reply. 2.42. What is the ratio of the Grants(current US$) in Senegal in 1996 to that in 2001?
Ensure brevity in your answer.  1.17. What is the ratio of the Grants(current US$) of Sri Lanka in 1996 to that in 2001?
Give a very brief answer. 1.25. What is the ratio of the Grants(current US$) in Antigua and Barbuda in 1997 to that in 1998?
Your answer should be compact. 0.55. What is the ratio of the Grants(current US$) in Estonia in 1997 to that in 1998?
Ensure brevity in your answer.  1.07. What is the ratio of the Grants(current US$) in Senegal in 1997 to that in 1998?
Provide a short and direct response. 1.16. What is the ratio of the Grants(current US$) of Sri Lanka in 1997 to that in 1998?
Make the answer very short. 1.17. What is the ratio of the Grants(current US$) of Antigua and Barbuda in 1997 to that in 1999?
Your answer should be compact. 0.8. What is the ratio of the Grants(current US$) in Estonia in 1997 to that in 1999?
Offer a terse response. 1.61. What is the ratio of the Grants(current US$) of Senegal in 1997 to that in 1999?
Your answer should be compact. 1.22. What is the ratio of the Grants(current US$) of Sri Lanka in 1997 to that in 1999?
Your answer should be very brief. 1.09. What is the ratio of the Grants(current US$) in Antigua and Barbuda in 1997 to that in 2000?
Provide a succinct answer. 0.9. What is the ratio of the Grants(current US$) of Estonia in 1997 to that in 2000?
Provide a succinct answer. 1.68. What is the ratio of the Grants(current US$) of Senegal in 1997 to that in 2000?
Provide a succinct answer. 1.25. What is the ratio of the Grants(current US$) of Sri Lanka in 1997 to that in 2000?
Provide a short and direct response. 1.21. What is the ratio of the Grants(current US$) of Antigua and Barbuda in 1997 to that in 2001?
Your answer should be compact. 0.58. What is the ratio of the Grants(current US$) of Estonia in 1997 to that in 2001?
Give a very brief answer. 2.05. What is the ratio of the Grants(current US$) of Senegal in 1997 to that in 2001?
Your answer should be compact. 1.09. What is the ratio of the Grants(current US$) in Sri Lanka in 1997 to that in 2001?
Your response must be concise. 1.22. What is the ratio of the Grants(current US$) in Antigua and Barbuda in 1998 to that in 1999?
Offer a terse response. 1.47. What is the ratio of the Grants(current US$) of Estonia in 1998 to that in 1999?
Provide a short and direct response. 1.5. What is the ratio of the Grants(current US$) of Senegal in 1998 to that in 1999?
Provide a short and direct response. 1.05. What is the ratio of the Grants(current US$) of Sri Lanka in 1998 to that in 1999?
Provide a short and direct response. 0.93. What is the ratio of the Grants(current US$) in Antigua and Barbuda in 1998 to that in 2000?
Your answer should be compact. 1.65. What is the ratio of the Grants(current US$) of Estonia in 1998 to that in 2000?
Provide a short and direct response. 1.57. What is the ratio of the Grants(current US$) in Senegal in 1998 to that in 2000?
Offer a terse response. 1.08. What is the ratio of the Grants(current US$) in Sri Lanka in 1998 to that in 2000?
Your response must be concise. 1.03. What is the ratio of the Grants(current US$) in Antigua and Barbuda in 1998 to that in 2001?
Provide a short and direct response. 1.06. What is the ratio of the Grants(current US$) in Estonia in 1998 to that in 2001?
Ensure brevity in your answer.  1.92. What is the ratio of the Grants(current US$) of Senegal in 1998 to that in 2001?
Provide a short and direct response. 0.94. What is the ratio of the Grants(current US$) in Sri Lanka in 1998 to that in 2001?
Provide a succinct answer. 1.04. What is the ratio of the Grants(current US$) of Antigua and Barbuda in 1999 to that in 2000?
Your answer should be very brief. 1.12. What is the ratio of the Grants(current US$) in Estonia in 1999 to that in 2000?
Offer a terse response. 1.04. What is the ratio of the Grants(current US$) in Senegal in 1999 to that in 2000?
Your response must be concise. 1.02. What is the ratio of the Grants(current US$) of Sri Lanka in 1999 to that in 2000?
Keep it short and to the point. 1.11. What is the ratio of the Grants(current US$) in Antigua and Barbuda in 1999 to that in 2001?
Make the answer very short. 0.72. What is the ratio of the Grants(current US$) of Estonia in 1999 to that in 2001?
Offer a terse response. 1.27. What is the ratio of the Grants(current US$) in Senegal in 1999 to that in 2001?
Your answer should be compact. 0.89. What is the ratio of the Grants(current US$) of Sri Lanka in 1999 to that in 2001?
Your answer should be compact. 1.12. What is the ratio of the Grants(current US$) in Antigua and Barbuda in 2000 to that in 2001?
Ensure brevity in your answer.  0.65. What is the ratio of the Grants(current US$) of Estonia in 2000 to that in 2001?
Offer a very short reply. 1.22. What is the ratio of the Grants(current US$) of Senegal in 2000 to that in 2001?
Your response must be concise. 0.88. What is the ratio of the Grants(current US$) in Sri Lanka in 2000 to that in 2001?
Ensure brevity in your answer.  1.01. What is the difference between the highest and the second highest Grants(current US$) of Antigua and Barbuda?
Offer a very short reply. 1.80e+05. What is the difference between the highest and the second highest Grants(current US$) in Estonia?
Provide a succinct answer. 1.34e+07. What is the difference between the highest and the second highest Grants(current US$) in Senegal?
Your response must be concise. 1.39e+07. What is the difference between the highest and the second highest Grants(current US$) of Sri Lanka?
Give a very brief answer. 1.63e+07. What is the difference between the highest and the lowest Grants(current US$) in Antigua and Barbuda?
Offer a terse response. 2.41e+06. What is the difference between the highest and the lowest Grants(current US$) of Estonia?
Make the answer very short. 2.71e+07. What is the difference between the highest and the lowest Grants(current US$) in Senegal?
Keep it short and to the point. 5.52e+07. What is the difference between the highest and the lowest Grants(current US$) in Sri Lanka?
Offer a very short reply. 3.71e+07. 